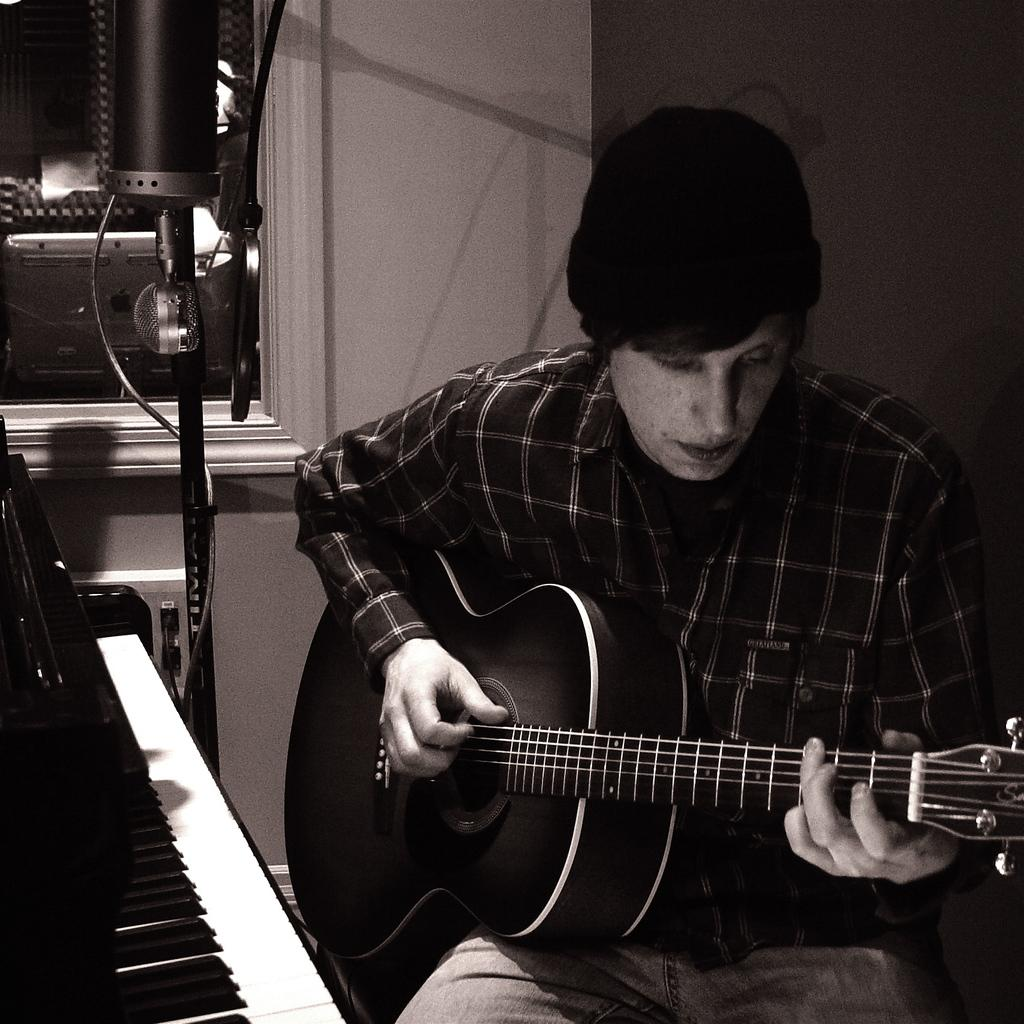What is the person in the image doing? The person is holding a guitar. What other musical instrument is visible in the image? There is a piano to the left of the person. What can be seen in the background of the image? There is a window in the background of the image. How does the person hold the airplane in the image? There is no airplane present in the image; the person is holding a guitar. What type of knot is tied around the grip of the guitar? There is no knot tied around the grip of the guitar in the image. 